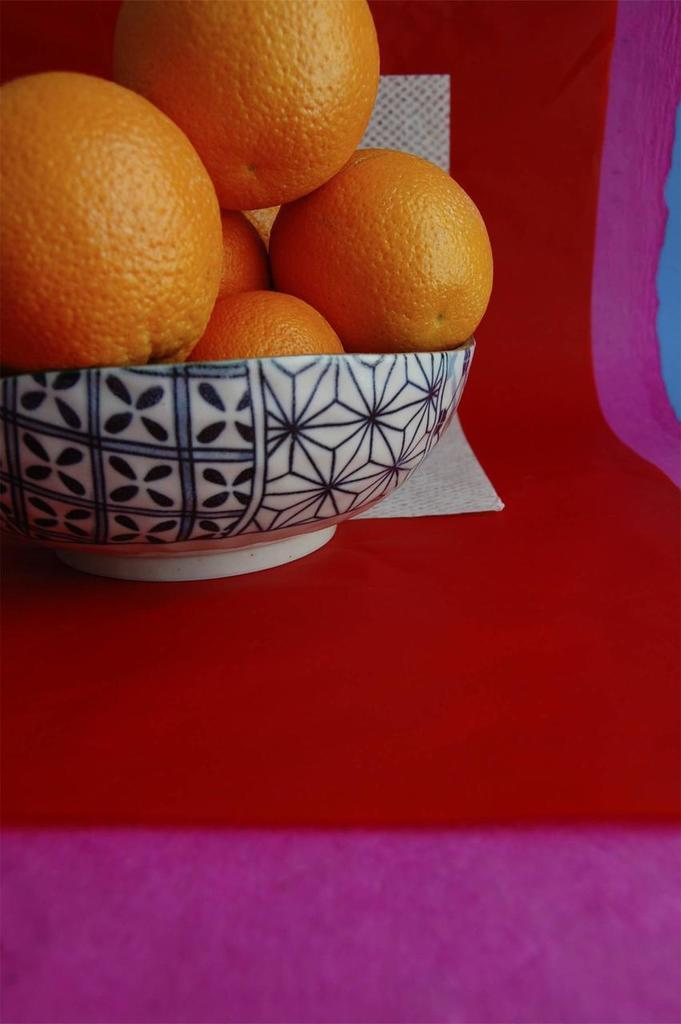What type of food can be seen in the bowl in the image? There are fruits in a bowl in the image. What is placed on the red cloth in the image? There is a paper on a red cloth in the image. Are there any cacti visible in the image? No, there are no cacti present in the image. What type of creature might be found in a crib in the image? There is no crib present in the image, so it is not possible to determine what type of creature might be found in a crib. 